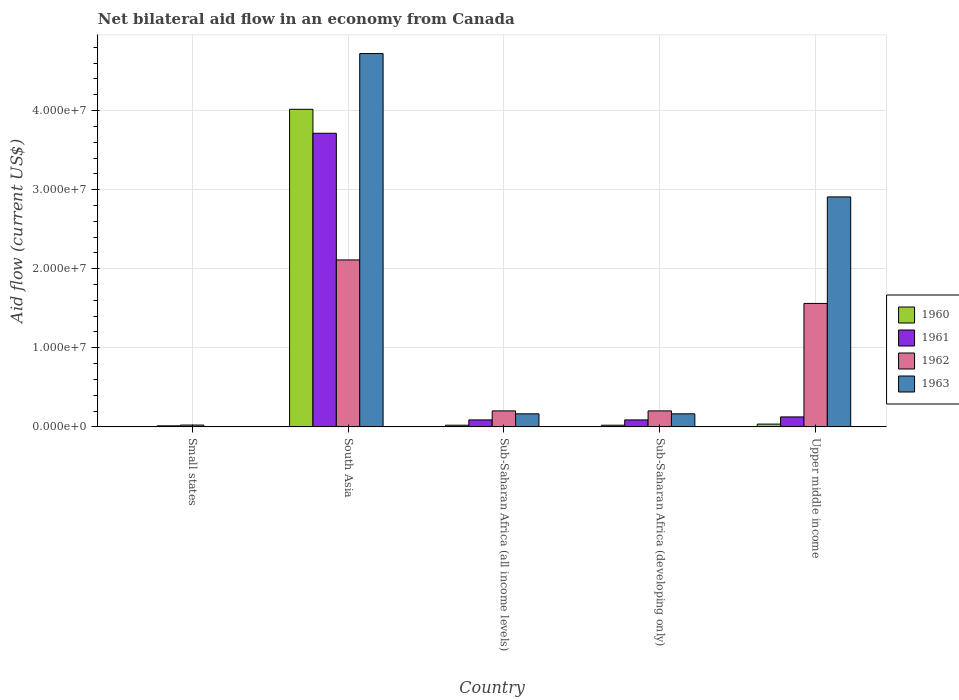What is the label of the 3rd group of bars from the left?
Keep it short and to the point. Sub-Saharan Africa (all income levels). What is the net bilateral aid flow in 1960 in Sub-Saharan Africa (developing only)?
Keep it short and to the point. 2.10e+05. Across all countries, what is the maximum net bilateral aid flow in 1961?
Your answer should be very brief. 3.71e+07. In which country was the net bilateral aid flow in 1962 maximum?
Offer a very short reply. South Asia. In which country was the net bilateral aid flow in 1963 minimum?
Provide a succinct answer. Small states. What is the total net bilateral aid flow in 1961 in the graph?
Ensure brevity in your answer.  4.03e+07. What is the difference between the net bilateral aid flow in 1962 in South Asia and that in Sub-Saharan Africa (all income levels)?
Keep it short and to the point. 1.91e+07. What is the difference between the net bilateral aid flow in 1961 in Upper middle income and the net bilateral aid flow in 1960 in Sub-Saharan Africa (all income levels)?
Your answer should be very brief. 1.05e+06. What is the average net bilateral aid flow in 1962 per country?
Your answer should be very brief. 8.20e+06. What is the difference between the net bilateral aid flow of/in 1960 and net bilateral aid flow of/in 1963 in Upper middle income?
Give a very brief answer. -2.87e+07. In how many countries, is the net bilateral aid flow in 1960 greater than 8000000 US$?
Ensure brevity in your answer.  1. What is the ratio of the net bilateral aid flow in 1960 in Sub-Saharan Africa (all income levels) to that in Upper middle income?
Ensure brevity in your answer.  0.6. Is the net bilateral aid flow in 1963 in Sub-Saharan Africa (developing only) less than that in Upper middle income?
Your answer should be compact. Yes. What is the difference between the highest and the second highest net bilateral aid flow in 1962?
Your answer should be very brief. 5.50e+06. What is the difference between the highest and the lowest net bilateral aid flow in 1961?
Your answer should be compact. 3.70e+07. Is it the case that in every country, the sum of the net bilateral aid flow in 1962 and net bilateral aid flow in 1963 is greater than the sum of net bilateral aid flow in 1961 and net bilateral aid flow in 1960?
Provide a succinct answer. No. How many countries are there in the graph?
Keep it short and to the point. 5. What is the difference between two consecutive major ticks on the Y-axis?
Make the answer very short. 1.00e+07. Does the graph contain any zero values?
Your answer should be very brief. No. Does the graph contain grids?
Your response must be concise. Yes. What is the title of the graph?
Provide a succinct answer. Net bilateral aid flow in an economy from Canada. What is the label or title of the X-axis?
Offer a terse response. Country. What is the Aid flow (current US$) of 1961 in Small states?
Make the answer very short. 1.30e+05. What is the Aid flow (current US$) in 1962 in Small states?
Give a very brief answer. 2.30e+05. What is the Aid flow (current US$) of 1963 in Small states?
Offer a terse response. 3.00e+04. What is the Aid flow (current US$) of 1960 in South Asia?
Provide a succinct answer. 4.02e+07. What is the Aid flow (current US$) of 1961 in South Asia?
Make the answer very short. 3.71e+07. What is the Aid flow (current US$) of 1962 in South Asia?
Your answer should be very brief. 2.11e+07. What is the Aid flow (current US$) in 1963 in South Asia?
Offer a very short reply. 4.72e+07. What is the Aid flow (current US$) of 1961 in Sub-Saharan Africa (all income levels)?
Provide a short and direct response. 8.80e+05. What is the Aid flow (current US$) of 1962 in Sub-Saharan Africa (all income levels)?
Ensure brevity in your answer.  2.02e+06. What is the Aid flow (current US$) of 1963 in Sub-Saharan Africa (all income levels)?
Keep it short and to the point. 1.65e+06. What is the Aid flow (current US$) in 1960 in Sub-Saharan Africa (developing only)?
Make the answer very short. 2.10e+05. What is the Aid flow (current US$) of 1961 in Sub-Saharan Africa (developing only)?
Provide a short and direct response. 8.80e+05. What is the Aid flow (current US$) of 1962 in Sub-Saharan Africa (developing only)?
Offer a terse response. 2.02e+06. What is the Aid flow (current US$) in 1963 in Sub-Saharan Africa (developing only)?
Keep it short and to the point. 1.65e+06. What is the Aid flow (current US$) of 1960 in Upper middle income?
Offer a terse response. 3.50e+05. What is the Aid flow (current US$) of 1961 in Upper middle income?
Provide a succinct answer. 1.26e+06. What is the Aid flow (current US$) in 1962 in Upper middle income?
Give a very brief answer. 1.56e+07. What is the Aid flow (current US$) of 1963 in Upper middle income?
Your answer should be compact. 2.91e+07. Across all countries, what is the maximum Aid flow (current US$) in 1960?
Your response must be concise. 4.02e+07. Across all countries, what is the maximum Aid flow (current US$) in 1961?
Your answer should be very brief. 3.71e+07. Across all countries, what is the maximum Aid flow (current US$) of 1962?
Provide a short and direct response. 2.11e+07. Across all countries, what is the maximum Aid flow (current US$) of 1963?
Your answer should be very brief. 4.72e+07. Across all countries, what is the minimum Aid flow (current US$) in 1960?
Give a very brief answer. 2.00e+04. Across all countries, what is the minimum Aid flow (current US$) of 1961?
Ensure brevity in your answer.  1.30e+05. Across all countries, what is the minimum Aid flow (current US$) of 1963?
Provide a succinct answer. 3.00e+04. What is the total Aid flow (current US$) in 1960 in the graph?
Keep it short and to the point. 4.10e+07. What is the total Aid flow (current US$) in 1961 in the graph?
Keep it short and to the point. 4.03e+07. What is the total Aid flow (current US$) in 1962 in the graph?
Your answer should be compact. 4.10e+07. What is the total Aid flow (current US$) in 1963 in the graph?
Your answer should be compact. 7.96e+07. What is the difference between the Aid flow (current US$) of 1960 in Small states and that in South Asia?
Offer a very short reply. -4.01e+07. What is the difference between the Aid flow (current US$) of 1961 in Small states and that in South Asia?
Your response must be concise. -3.70e+07. What is the difference between the Aid flow (current US$) in 1962 in Small states and that in South Asia?
Offer a terse response. -2.09e+07. What is the difference between the Aid flow (current US$) of 1963 in Small states and that in South Asia?
Your response must be concise. -4.72e+07. What is the difference between the Aid flow (current US$) in 1960 in Small states and that in Sub-Saharan Africa (all income levels)?
Provide a succinct answer. -1.90e+05. What is the difference between the Aid flow (current US$) of 1961 in Small states and that in Sub-Saharan Africa (all income levels)?
Ensure brevity in your answer.  -7.50e+05. What is the difference between the Aid flow (current US$) of 1962 in Small states and that in Sub-Saharan Africa (all income levels)?
Give a very brief answer. -1.79e+06. What is the difference between the Aid flow (current US$) of 1963 in Small states and that in Sub-Saharan Africa (all income levels)?
Provide a succinct answer. -1.62e+06. What is the difference between the Aid flow (current US$) in 1961 in Small states and that in Sub-Saharan Africa (developing only)?
Make the answer very short. -7.50e+05. What is the difference between the Aid flow (current US$) of 1962 in Small states and that in Sub-Saharan Africa (developing only)?
Ensure brevity in your answer.  -1.79e+06. What is the difference between the Aid flow (current US$) of 1963 in Small states and that in Sub-Saharan Africa (developing only)?
Give a very brief answer. -1.62e+06. What is the difference between the Aid flow (current US$) of 1960 in Small states and that in Upper middle income?
Your answer should be very brief. -3.30e+05. What is the difference between the Aid flow (current US$) in 1961 in Small states and that in Upper middle income?
Your response must be concise. -1.13e+06. What is the difference between the Aid flow (current US$) in 1962 in Small states and that in Upper middle income?
Make the answer very short. -1.54e+07. What is the difference between the Aid flow (current US$) of 1963 in Small states and that in Upper middle income?
Provide a succinct answer. -2.90e+07. What is the difference between the Aid flow (current US$) of 1960 in South Asia and that in Sub-Saharan Africa (all income levels)?
Provide a succinct answer. 4.00e+07. What is the difference between the Aid flow (current US$) in 1961 in South Asia and that in Sub-Saharan Africa (all income levels)?
Keep it short and to the point. 3.62e+07. What is the difference between the Aid flow (current US$) of 1962 in South Asia and that in Sub-Saharan Africa (all income levels)?
Provide a short and direct response. 1.91e+07. What is the difference between the Aid flow (current US$) in 1963 in South Asia and that in Sub-Saharan Africa (all income levels)?
Make the answer very short. 4.56e+07. What is the difference between the Aid flow (current US$) in 1960 in South Asia and that in Sub-Saharan Africa (developing only)?
Offer a very short reply. 4.00e+07. What is the difference between the Aid flow (current US$) in 1961 in South Asia and that in Sub-Saharan Africa (developing only)?
Provide a succinct answer. 3.62e+07. What is the difference between the Aid flow (current US$) in 1962 in South Asia and that in Sub-Saharan Africa (developing only)?
Offer a very short reply. 1.91e+07. What is the difference between the Aid flow (current US$) of 1963 in South Asia and that in Sub-Saharan Africa (developing only)?
Provide a short and direct response. 4.56e+07. What is the difference between the Aid flow (current US$) in 1960 in South Asia and that in Upper middle income?
Offer a terse response. 3.98e+07. What is the difference between the Aid flow (current US$) of 1961 in South Asia and that in Upper middle income?
Ensure brevity in your answer.  3.59e+07. What is the difference between the Aid flow (current US$) in 1962 in South Asia and that in Upper middle income?
Your answer should be very brief. 5.50e+06. What is the difference between the Aid flow (current US$) of 1963 in South Asia and that in Upper middle income?
Provide a short and direct response. 1.81e+07. What is the difference between the Aid flow (current US$) in 1960 in Sub-Saharan Africa (all income levels) and that in Sub-Saharan Africa (developing only)?
Provide a short and direct response. 0. What is the difference between the Aid flow (current US$) in 1961 in Sub-Saharan Africa (all income levels) and that in Sub-Saharan Africa (developing only)?
Offer a terse response. 0. What is the difference between the Aid flow (current US$) of 1960 in Sub-Saharan Africa (all income levels) and that in Upper middle income?
Ensure brevity in your answer.  -1.40e+05. What is the difference between the Aid flow (current US$) in 1961 in Sub-Saharan Africa (all income levels) and that in Upper middle income?
Ensure brevity in your answer.  -3.80e+05. What is the difference between the Aid flow (current US$) of 1962 in Sub-Saharan Africa (all income levels) and that in Upper middle income?
Provide a short and direct response. -1.36e+07. What is the difference between the Aid flow (current US$) in 1963 in Sub-Saharan Africa (all income levels) and that in Upper middle income?
Your answer should be very brief. -2.74e+07. What is the difference between the Aid flow (current US$) in 1960 in Sub-Saharan Africa (developing only) and that in Upper middle income?
Provide a short and direct response. -1.40e+05. What is the difference between the Aid flow (current US$) in 1961 in Sub-Saharan Africa (developing only) and that in Upper middle income?
Offer a terse response. -3.80e+05. What is the difference between the Aid flow (current US$) in 1962 in Sub-Saharan Africa (developing only) and that in Upper middle income?
Keep it short and to the point. -1.36e+07. What is the difference between the Aid flow (current US$) of 1963 in Sub-Saharan Africa (developing only) and that in Upper middle income?
Make the answer very short. -2.74e+07. What is the difference between the Aid flow (current US$) in 1960 in Small states and the Aid flow (current US$) in 1961 in South Asia?
Give a very brief answer. -3.71e+07. What is the difference between the Aid flow (current US$) in 1960 in Small states and the Aid flow (current US$) in 1962 in South Asia?
Ensure brevity in your answer.  -2.11e+07. What is the difference between the Aid flow (current US$) in 1960 in Small states and the Aid flow (current US$) in 1963 in South Asia?
Make the answer very short. -4.72e+07. What is the difference between the Aid flow (current US$) in 1961 in Small states and the Aid flow (current US$) in 1962 in South Asia?
Keep it short and to the point. -2.10e+07. What is the difference between the Aid flow (current US$) in 1961 in Small states and the Aid flow (current US$) in 1963 in South Asia?
Keep it short and to the point. -4.71e+07. What is the difference between the Aid flow (current US$) in 1962 in Small states and the Aid flow (current US$) in 1963 in South Asia?
Ensure brevity in your answer.  -4.70e+07. What is the difference between the Aid flow (current US$) of 1960 in Small states and the Aid flow (current US$) of 1961 in Sub-Saharan Africa (all income levels)?
Ensure brevity in your answer.  -8.60e+05. What is the difference between the Aid flow (current US$) of 1960 in Small states and the Aid flow (current US$) of 1963 in Sub-Saharan Africa (all income levels)?
Provide a short and direct response. -1.63e+06. What is the difference between the Aid flow (current US$) of 1961 in Small states and the Aid flow (current US$) of 1962 in Sub-Saharan Africa (all income levels)?
Offer a terse response. -1.89e+06. What is the difference between the Aid flow (current US$) of 1961 in Small states and the Aid flow (current US$) of 1963 in Sub-Saharan Africa (all income levels)?
Keep it short and to the point. -1.52e+06. What is the difference between the Aid flow (current US$) of 1962 in Small states and the Aid flow (current US$) of 1963 in Sub-Saharan Africa (all income levels)?
Offer a very short reply. -1.42e+06. What is the difference between the Aid flow (current US$) in 1960 in Small states and the Aid flow (current US$) in 1961 in Sub-Saharan Africa (developing only)?
Offer a very short reply. -8.60e+05. What is the difference between the Aid flow (current US$) of 1960 in Small states and the Aid flow (current US$) of 1962 in Sub-Saharan Africa (developing only)?
Provide a succinct answer. -2.00e+06. What is the difference between the Aid flow (current US$) of 1960 in Small states and the Aid flow (current US$) of 1963 in Sub-Saharan Africa (developing only)?
Ensure brevity in your answer.  -1.63e+06. What is the difference between the Aid flow (current US$) in 1961 in Small states and the Aid flow (current US$) in 1962 in Sub-Saharan Africa (developing only)?
Your answer should be very brief. -1.89e+06. What is the difference between the Aid flow (current US$) in 1961 in Small states and the Aid flow (current US$) in 1963 in Sub-Saharan Africa (developing only)?
Give a very brief answer. -1.52e+06. What is the difference between the Aid flow (current US$) of 1962 in Small states and the Aid flow (current US$) of 1963 in Sub-Saharan Africa (developing only)?
Ensure brevity in your answer.  -1.42e+06. What is the difference between the Aid flow (current US$) of 1960 in Small states and the Aid flow (current US$) of 1961 in Upper middle income?
Give a very brief answer. -1.24e+06. What is the difference between the Aid flow (current US$) of 1960 in Small states and the Aid flow (current US$) of 1962 in Upper middle income?
Your answer should be compact. -1.56e+07. What is the difference between the Aid flow (current US$) of 1960 in Small states and the Aid flow (current US$) of 1963 in Upper middle income?
Keep it short and to the point. -2.91e+07. What is the difference between the Aid flow (current US$) in 1961 in Small states and the Aid flow (current US$) in 1962 in Upper middle income?
Offer a very short reply. -1.55e+07. What is the difference between the Aid flow (current US$) of 1961 in Small states and the Aid flow (current US$) of 1963 in Upper middle income?
Provide a short and direct response. -2.90e+07. What is the difference between the Aid flow (current US$) of 1962 in Small states and the Aid flow (current US$) of 1963 in Upper middle income?
Your answer should be compact. -2.88e+07. What is the difference between the Aid flow (current US$) in 1960 in South Asia and the Aid flow (current US$) in 1961 in Sub-Saharan Africa (all income levels)?
Your response must be concise. 3.93e+07. What is the difference between the Aid flow (current US$) of 1960 in South Asia and the Aid flow (current US$) of 1962 in Sub-Saharan Africa (all income levels)?
Your response must be concise. 3.81e+07. What is the difference between the Aid flow (current US$) of 1960 in South Asia and the Aid flow (current US$) of 1963 in Sub-Saharan Africa (all income levels)?
Your answer should be compact. 3.85e+07. What is the difference between the Aid flow (current US$) in 1961 in South Asia and the Aid flow (current US$) in 1962 in Sub-Saharan Africa (all income levels)?
Keep it short and to the point. 3.51e+07. What is the difference between the Aid flow (current US$) in 1961 in South Asia and the Aid flow (current US$) in 1963 in Sub-Saharan Africa (all income levels)?
Provide a succinct answer. 3.55e+07. What is the difference between the Aid flow (current US$) of 1962 in South Asia and the Aid flow (current US$) of 1963 in Sub-Saharan Africa (all income levels)?
Give a very brief answer. 1.95e+07. What is the difference between the Aid flow (current US$) in 1960 in South Asia and the Aid flow (current US$) in 1961 in Sub-Saharan Africa (developing only)?
Keep it short and to the point. 3.93e+07. What is the difference between the Aid flow (current US$) in 1960 in South Asia and the Aid flow (current US$) in 1962 in Sub-Saharan Africa (developing only)?
Your response must be concise. 3.81e+07. What is the difference between the Aid flow (current US$) of 1960 in South Asia and the Aid flow (current US$) of 1963 in Sub-Saharan Africa (developing only)?
Your response must be concise. 3.85e+07. What is the difference between the Aid flow (current US$) of 1961 in South Asia and the Aid flow (current US$) of 1962 in Sub-Saharan Africa (developing only)?
Give a very brief answer. 3.51e+07. What is the difference between the Aid flow (current US$) of 1961 in South Asia and the Aid flow (current US$) of 1963 in Sub-Saharan Africa (developing only)?
Provide a succinct answer. 3.55e+07. What is the difference between the Aid flow (current US$) in 1962 in South Asia and the Aid flow (current US$) in 1963 in Sub-Saharan Africa (developing only)?
Your response must be concise. 1.95e+07. What is the difference between the Aid flow (current US$) of 1960 in South Asia and the Aid flow (current US$) of 1961 in Upper middle income?
Keep it short and to the point. 3.89e+07. What is the difference between the Aid flow (current US$) in 1960 in South Asia and the Aid flow (current US$) in 1962 in Upper middle income?
Make the answer very short. 2.46e+07. What is the difference between the Aid flow (current US$) in 1960 in South Asia and the Aid flow (current US$) in 1963 in Upper middle income?
Ensure brevity in your answer.  1.11e+07. What is the difference between the Aid flow (current US$) in 1961 in South Asia and the Aid flow (current US$) in 1962 in Upper middle income?
Keep it short and to the point. 2.15e+07. What is the difference between the Aid flow (current US$) in 1961 in South Asia and the Aid flow (current US$) in 1963 in Upper middle income?
Give a very brief answer. 8.05e+06. What is the difference between the Aid flow (current US$) in 1962 in South Asia and the Aid flow (current US$) in 1963 in Upper middle income?
Provide a succinct answer. -7.97e+06. What is the difference between the Aid flow (current US$) in 1960 in Sub-Saharan Africa (all income levels) and the Aid flow (current US$) in 1961 in Sub-Saharan Africa (developing only)?
Offer a terse response. -6.70e+05. What is the difference between the Aid flow (current US$) in 1960 in Sub-Saharan Africa (all income levels) and the Aid flow (current US$) in 1962 in Sub-Saharan Africa (developing only)?
Your response must be concise. -1.81e+06. What is the difference between the Aid flow (current US$) of 1960 in Sub-Saharan Africa (all income levels) and the Aid flow (current US$) of 1963 in Sub-Saharan Africa (developing only)?
Keep it short and to the point. -1.44e+06. What is the difference between the Aid flow (current US$) of 1961 in Sub-Saharan Africa (all income levels) and the Aid flow (current US$) of 1962 in Sub-Saharan Africa (developing only)?
Provide a succinct answer. -1.14e+06. What is the difference between the Aid flow (current US$) in 1961 in Sub-Saharan Africa (all income levels) and the Aid flow (current US$) in 1963 in Sub-Saharan Africa (developing only)?
Make the answer very short. -7.70e+05. What is the difference between the Aid flow (current US$) in 1962 in Sub-Saharan Africa (all income levels) and the Aid flow (current US$) in 1963 in Sub-Saharan Africa (developing only)?
Provide a succinct answer. 3.70e+05. What is the difference between the Aid flow (current US$) in 1960 in Sub-Saharan Africa (all income levels) and the Aid flow (current US$) in 1961 in Upper middle income?
Give a very brief answer. -1.05e+06. What is the difference between the Aid flow (current US$) in 1960 in Sub-Saharan Africa (all income levels) and the Aid flow (current US$) in 1962 in Upper middle income?
Provide a short and direct response. -1.54e+07. What is the difference between the Aid flow (current US$) of 1960 in Sub-Saharan Africa (all income levels) and the Aid flow (current US$) of 1963 in Upper middle income?
Your answer should be very brief. -2.89e+07. What is the difference between the Aid flow (current US$) in 1961 in Sub-Saharan Africa (all income levels) and the Aid flow (current US$) in 1962 in Upper middle income?
Ensure brevity in your answer.  -1.47e+07. What is the difference between the Aid flow (current US$) of 1961 in Sub-Saharan Africa (all income levels) and the Aid flow (current US$) of 1963 in Upper middle income?
Provide a succinct answer. -2.82e+07. What is the difference between the Aid flow (current US$) of 1962 in Sub-Saharan Africa (all income levels) and the Aid flow (current US$) of 1963 in Upper middle income?
Keep it short and to the point. -2.71e+07. What is the difference between the Aid flow (current US$) in 1960 in Sub-Saharan Africa (developing only) and the Aid flow (current US$) in 1961 in Upper middle income?
Your answer should be very brief. -1.05e+06. What is the difference between the Aid flow (current US$) of 1960 in Sub-Saharan Africa (developing only) and the Aid flow (current US$) of 1962 in Upper middle income?
Your answer should be compact. -1.54e+07. What is the difference between the Aid flow (current US$) in 1960 in Sub-Saharan Africa (developing only) and the Aid flow (current US$) in 1963 in Upper middle income?
Provide a short and direct response. -2.89e+07. What is the difference between the Aid flow (current US$) of 1961 in Sub-Saharan Africa (developing only) and the Aid flow (current US$) of 1962 in Upper middle income?
Provide a succinct answer. -1.47e+07. What is the difference between the Aid flow (current US$) in 1961 in Sub-Saharan Africa (developing only) and the Aid flow (current US$) in 1963 in Upper middle income?
Make the answer very short. -2.82e+07. What is the difference between the Aid flow (current US$) of 1962 in Sub-Saharan Africa (developing only) and the Aid flow (current US$) of 1963 in Upper middle income?
Provide a short and direct response. -2.71e+07. What is the average Aid flow (current US$) of 1960 per country?
Your answer should be compact. 8.19e+06. What is the average Aid flow (current US$) of 1961 per country?
Offer a very short reply. 8.06e+06. What is the average Aid flow (current US$) of 1962 per country?
Ensure brevity in your answer.  8.20e+06. What is the average Aid flow (current US$) of 1963 per country?
Provide a short and direct response. 1.59e+07. What is the difference between the Aid flow (current US$) of 1960 and Aid flow (current US$) of 1961 in Small states?
Provide a short and direct response. -1.10e+05. What is the difference between the Aid flow (current US$) in 1961 and Aid flow (current US$) in 1962 in Small states?
Your answer should be compact. -1.00e+05. What is the difference between the Aid flow (current US$) of 1960 and Aid flow (current US$) of 1961 in South Asia?
Give a very brief answer. 3.03e+06. What is the difference between the Aid flow (current US$) in 1960 and Aid flow (current US$) in 1962 in South Asia?
Your response must be concise. 1.90e+07. What is the difference between the Aid flow (current US$) of 1960 and Aid flow (current US$) of 1963 in South Asia?
Offer a terse response. -7.05e+06. What is the difference between the Aid flow (current US$) of 1961 and Aid flow (current US$) of 1962 in South Asia?
Offer a terse response. 1.60e+07. What is the difference between the Aid flow (current US$) in 1961 and Aid flow (current US$) in 1963 in South Asia?
Offer a very short reply. -1.01e+07. What is the difference between the Aid flow (current US$) of 1962 and Aid flow (current US$) of 1963 in South Asia?
Offer a terse response. -2.61e+07. What is the difference between the Aid flow (current US$) in 1960 and Aid flow (current US$) in 1961 in Sub-Saharan Africa (all income levels)?
Keep it short and to the point. -6.70e+05. What is the difference between the Aid flow (current US$) in 1960 and Aid flow (current US$) in 1962 in Sub-Saharan Africa (all income levels)?
Provide a succinct answer. -1.81e+06. What is the difference between the Aid flow (current US$) of 1960 and Aid flow (current US$) of 1963 in Sub-Saharan Africa (all income levels)?
Offer a very short reply. -1.44e+06. What is the difference between the Aid flow (current US$) in 1961 and Aid flow (current US$) in 1962 in Sub-Saharan Africa (all income levels)?
Make the answer very short. -1.14e+06. What is the difference between the Aid flow (current US$) of 1961 and Aid flow (current US$) of 1963 in Sub-Saharan Africa (all income levels)?
Ensure brevity in your answer.  -7.70e+05. What is the difference between the Aid flow (current US$) of 1960 and Aid flow (current US$) of 1961 in Sub-Saharan Africa (developing only)?
Make the answer very short. -6.70e+05. What is the difference between the Aid flow (current US$) of 1960 and Aid flow (current US$) of 1962 in Sub-Saharan Africa (developing only)?
Your answer should be compact. -1.81e+06. What is the difference between the Aid flow (current US$) of 1960 and Aid flow (current US$) of 1963 in Sub-Saharan Africa (developing only)?
Your answer should be very brief. -1.44e+06. What is the difference between the Aid flow (current US$) in 1961 and Aid flow (current US$) in 1962 in Sub-Saharan Africa (developing only)?
Provide a short and direct response. -1.14e+06. What is the difference between the Aid flow (current US$) of 1961 and Aid flow (current US$) of 1963 in Sub-Saharan Africa (developing only)?
Keep it short and to the point. -7.70e+05. What is the difference between the Aid flow (current US$) of 1962 and Aid flow (current US$) of 1963 in Sub-Saharan Africa (developing only)?
Keep it short and to the point. 3.70e+05. What is the difference between the Aid flow (current US$) in 1960 and Aid flow (current US$) in 1961 in Upper middle income?
Offer a very short reply. -9.10e+05. What is the difference between the Aid flow (current US$) in 1960 and Aid flow (current US$) in 1962 in Upper middle income?
Provide a short and direct response. -1.53e+07. What is the difference between the Aid flow (current US$) of 1960 and Aid flow (current US$) of 1963 in Upper middle income?
Your response must be concise. -2.87e+07. What is the difference between the Aid flow (current US$) in 1961 and Aid flow (current US$) in 1962 in Upper middle income?
Your response must be concise. -1.44e+07. What is the difference between the Aid flow (current US$) in 1961 and Aid flow (current US$) in 1963 in Upper middle income?
Your response must be concise. -2.78e+07. What is the difference between the Aid flow (current US$) in 1962 and Aid flow (current US$) in 1963 in Upper middle income?
Make the answer very short. -1.35e+07. What is the ratio of the Aid flow (current US$) in 1961 in Small states to that in South Asia?
Make the answer very short. 0. What is the ratio of the Aid flow (current US$) in 1962 in Small states to that in South Asia?
Offer a terse response. 0.01. What is the ratio of the Aid flow (current US$) of 1963 in Small states to that in South Asia?
Ensure brevity in your answer.  0. What is the ratio of the Aid flow (current US$) in 1960 in Small states to that in Sub-Saharan Africa (all income levels)?
Your answer should be very brief. 0.1. What is the ratio of the Aid flow (current US$) in 1961 in Small states to that in Sub-Saharan Africa (all income levels)?
Make the answer very short. 0.15. What is the ratio of the Aid flow (current US$) in 1962 in Small states to that in Sub-Saharan Africa (all income levels)?
Provide a succinct answer. 0.11. What is the ratio of the Aid flow (current US$) of 1963 in Small states to that in Sub-Saharan Africa (all income levels)?
Your answer should be compact. 0.02. What is the ratio of the Aid flow (current US$) of 1960 in Small states to that in Sub-Saharan Africa (developing only)?
Your response must be concise. 0.1. What is the ratio of the Aid flow (current US$) of 1961 in Small states to that in Sub-Saharan Africa (developing only)?
Ensure brevity in your answer.  0.15. What is the ratio of the Aid flow (current US$) of 1962 in Small states to that in Sub-Saharan Africa (developing only)?
Provide a succinct answer. 0.11. What is the ratio of the Aid flow (current US$) in 1963 in Small states to that in Sub-Saharan Africa (developing only)?
Ensure brevity in your answer.  0.02. What is the ratio of the Aid flow (current US$) in 1960 in Small states to that in Upper middle income?
Provide a short and direct response. 0.06. What is the ratio of the Aid flow (current US$) in 1961 in Small states to that in Upper middle income?
Your answer should be compact. 0.1. What is the ratio of the Aid flow (current US$) of 1962 in Small states to that in Upper middle income?
Ensure brevity in your answer.  0.01. What is the ratio of the Aid flow (current US$) in 1960 in South Asia to that in Sub-Saharan Africa (all income levels)?
Your answer should be very brief. 191.24. What is the ratio of the Aid flow (current US$) of 1961 in South Asia to that in Sub-Saharan Africa (all income levels)?
Make the answer very short. 42.19. What is the ratio of the Aid flow (current US$) of 1962 in South Asia to that in Sub-Saharan Africa (all income levels)?
Offer a terse response. 10.45. What is the ratio of the Aid flow (current US$) of 1963 in South Asia to that in Sub-Saharan Africa (all income levels)?
Your response must be concise. 28.61. What is the ratio of the Aid flow (current US$) of 1960 in South Asia to that in Sub-Saharan Africa (developing only)?
Provide a short and direct response. 191.24. What is the ratio of the Aid flow (current US$) of 1961 in South Asia to that in Sub-Saharan Africa (developing only)?
Your answer should be very brief. 42.19. What is the ratio of the Aid flow (current US$) in 1962 in South Asia to that in Sub-Saharan Africa (developing only)?
Give a very brief answer. 10.45. What is the ratio of the Aid flow (current US$) of 1963 in South Asia to that in Sub-Saharan Africa (developing only)?
Provide a succinct answer. 28.61. What is the ratio of the Aid flow (current US$) in 1960 in South Asia to that in Upper middle income?
Your response must be concise. 114.74. What is the ratio of the Aid flow (current US$) in 1961 in South Asia to that in Upper middle income?
Your answer should be compact. 29.47. What is the ratio of the Aid flow (current US$) of 1962 in South Asia to that in Upper middle income?
Your response must be concise. 1.35. What is the ratio of the Aid flow (current US$) of 1963 in South Asia to that in Upper middle income?
Offer a very short reply. 1.62. What is the ratio of the Aid flow (current US$) in 1963 in Sub-Saharan Africa (all income levels) to that in Sub-Saharan Africa (developing only)?
Your answer should be compact. 1. What is the ratio of the Aid flow (current US$) in 1960 in Sub-Saharan Africa (all income levels) to that in Upper middle income?
Your response must be concise. 0.6. What is the ratio of the Aid flow (current US$) of 1961 in Sub-Saharan Africa (all income levels) to that in Upper middle income?
Make the answer very short. 0.7. What is the ratio of the Aid flow (current US$) in 1962 in Sub-Saharan Africa (all income levels) to that in Upper middle income?
Your answer should be very brief. 0.13. What is the ratio of the Aid flow (current US$) in 1963 in Sub-Saharan Africa (all income levels) to that in Upper middle income?
Offer a terse response. 0.06. What is the ratio of the Aid flow (current US$) in 1960 in Sub-Saharan Africa (developing only) to that in Upper middle income?
Your answer should be very brief. 0.6. What is the ratio of the Aid flow (current US$) of 1961 in Sub-Saharan Africa (developing only) to that in Upper middle income?
Give a very brief answer. 0.7. What is the ratio of the Aid flow (current US$) in 1962 in Sub-Saharan Africa (developing only) to that in Upper middle income?
Give a very brief answer. 0.13. What is the ratio of the Aid flow (current US$) in 1963 in Sub-Saharan Africa (developing only) to that in Upper middle income?
Your response must be concise. 0.06. What is the difference between the highest and the second highest Aid flow (current US$) in 1960?
Provide a succinct answer. 3.98e+07. What is the difference between the highest and the second highest Aid flow (current US$) in 1961?
Your response must be concise. 3.59e+07. What is the difference between the highest and the second highest Aid flow (current US$) in 1962?
Provide a succinct answer. 5.50e+06. What is the difference between the highest and the second highest Aid flow (current US$) of 1963?
Your answer should be compact. 1.81e+07. What is the difference between the highest and the lowest Aid flow (current US$) in 1960?
Offer a very short reply. 4.01e+07. What is the difference between the highest and the lowest Aid flow (current US$) of 1961?
Make the answer very short. 3.70e+07. What is the difference between the highest and the lowest Aid flow (current US$) of 1962?
Provide a succinct answer. 2.09e+07. What is the difference between the highest and the lowest Aid flow (current US$) in 1963?
Give a very brief answer. 4.72e+07. 